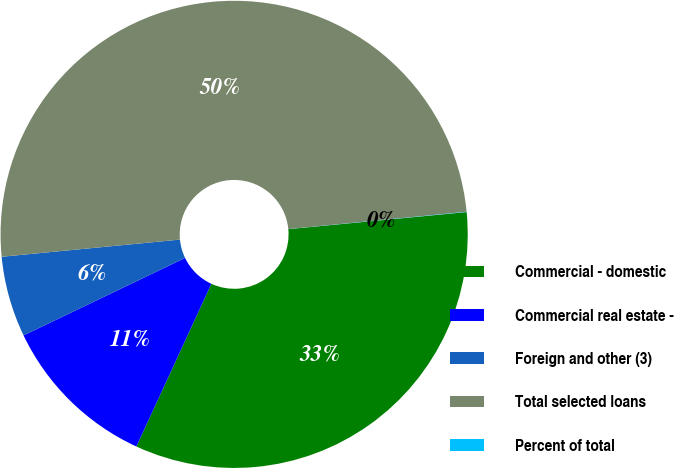Convert chart. <chart><loc_0><loc_0><loc_500><loc_500><pie_chart><fcel>Commercial - domestic<fcel>Commercial real estate -<fcel>Foreign and other (3)<fcel>Total selected loans<fcel>Percent of total<nl><fcel>33.4%<fcel>11.01%<fcel>5.59%<fcel>49.99%<fcel>0.02%<nl></chart> 